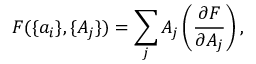Convert formula to latex. <formula><loc_0><loc_0><loc_500><loc_500>F ( \{ a _ { i } \} , \{ A _ { j } \} ) = \sum _ { j } A _ { j } \left ( { \frac { \partial F } { \partial A _ { j } } } \right ) ,</formula> 